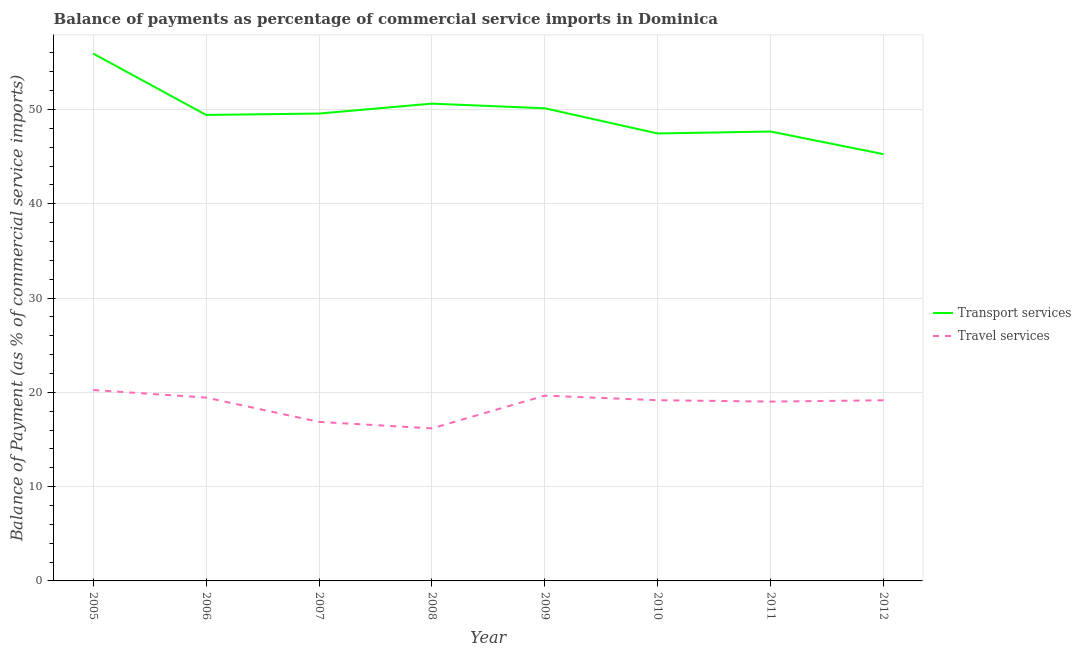How many different coloured lines are there?
Ensure brevity in your answer.  2. What is the balance of payments of travel services in 2005?
Your response must be concise. 20.25. Across all years, what is the maximum balance of payments of transport services?
Give a very brief answer. 55.92. Across all years, what is the minimum balance of payments of travel services?
Your answer should be very brief. 16.18. In which year was the balance of payments of transport services minimum?
Offer a very short reply. 2012. What is the total balance of payments of travel services in the graph?
Offer a very short reply. 149.72. What is the difference between the balance of payments of travel services in 2007 and that in 2010?
Your answer should be very brief. -2.3. What is the difference between the balance of payments of transport services in 2010 and the balance of payments of travel services in 2009?
Your answer should be very brief. 27.8. What is the average balance of payments of transport services per year?
Make the answer very short. 49.5. In the year 2012, what is the difference between the balance of payments of transport services and balance of payments of travel services?
Provide a short and direct response. 26.11. What is the ratio of the balance of payments of travel services in 2005 to that in 2011?
Ensure brevity in your answer.  1.06. Is the balance of payments of travel services in 2008 less than that in 2012?
Provide a short and direct response. Yes. Is the difference between the balance of payments of transport services in 2008 and 2009 greater than the difference between the balance of payments of travel services in 2008 and 2009?
Your answer should be very brief. Yes. What is the difference between the highest and the second highest balance of payments of transport services?
Your response must be concise. 5.31. What is the difference between the highest and the lowest balance of payments of transport services?
Provide a short and direct response. 10.66. Is the sum of the balance of payments of transport services in 2005 and 2006 greater than the maximum balance of payments of travel services across all years?
Offer a very short reply. Yes. Is the balance of payments of transport services strictly less than the balance of payments of travel services over the years?
Provide a succinct answer. No. How many lines are there?
Provide a succinct answer. 2. How many years are there in the graph?
Your answer should be very brief. 8. What is the difference between two consecutive major ticks on the Y-axis?
Provide a short and direct response. 10. Are the values on the major ticks of Y-axis written in scientific E-notation?
Keep it short and to the point. No. Does the graph contain any zero values?
Provide a succinct answer. No. Does the graph contain grids?
Ensure brevity in your answer.  Yes. Where does the legend appear in the graph?
Your answer should be very brief. Center right. How many legend labels are there?
Provide a succinct answer. 2. How are the legend labels stacked?
Provide a succinct answer. Vertical. What is the title of the graph?
Offer a terse response. Balance of payments as percentage of commercial service imports in Dominica. What is the label or title of the Y-axis?
Provide a succinct answer. Balance of Payment (as % of commercial service imports). What is the Balance of Payment (as % of commercial service imports) in Transport services in 2005?
Give a very brief answer. 55.92. What is the Balance of Payment (as % of commercial service imports) of Travel services in 2005?
Provide a succinct answer. 20.25. What is the Balance of Payment (as % of commercial service imports) of Transport services in 2006?
Offer a terse response. 49.42. What is the Balance of Payment (as % of commercial service imports) of Travel services in 2006?
Keep it short and to the point. 19.44. What is the Balance of Payment (as % of commercial service imports) in Transport services in 2007?
Provide a short and direct response. 49.57. What is the Balance of Payment (as % of commercial service imports) of Travel services in 2007?
Your response must be concise. 16.87. What is the Balance of Payment (as % of commercial service imports) of Transport services in 2008?
Offer a very short reply. 50.62. What is the Balance of Payment (as % of commercial service imports) of Travel services in 2008?
Your answer should be very brief. 16.18. What is the Balance of Payment (as % of commercial service imports) of Transport services in 2009?
Keep it short and to the point. 50.12. What is the Balance of Payment (as % of commercial service imports) of Travel services in 2009?
Provide a succinct answer. 19.65. What is the Balance of Payment (as % of commercial service imports) of Transport services in 2010?
Provide a succinct answer. 47.45. What is the Balance of Payment (as % of commercial service imports) of Travel services in 2010?
Keep it short and to the point. 19.17. What is the Balance of Payment (as % of commercial service imports) of Transport services in 2011?
Keep it short and to the point. 47.66. What is the Balance of Payment (as % of commercial service imports) of Travel services in 2011?
Keep it short and to the point. 19.02. What is the Balance of Payment (as % of commercial service imports) in Transport services in 2012?
Give a very brief answer. 45.26. What is the Balance of Payment (as % of commercial service imports) of Travel services in 2012?
Offer a terse response. 19.16. Across all years, what is the maximum Balance of Payment (as % of commercial service imports) of Transport services?
Ensure brevity in your answer.  55.92. Across all years, what is the maximum Balance of Payment (as % of commercial service imports) in Travel services?
Your response must be concise. 20.25. Across all years, what is the minimum Balance of Payment (as % of commercial service imports) in Transport services?
Offer a very short reply. 45.26. Across all years, what is the minimum Balance of Payment (as % of commercial service imports) of Travel services?
Ensure brevity in your answer.  16.18. What is the total Balance of Payment (as % of commercial service imports) in Transport services in the graph?
Offer a very short reply. 396.03. What is the total Balance of Payment (as % of commercial service imports) of Travel services in the graph?
Your response must be concise. 149.72. What is the difference between the Balance of Payment (as % of commercial service imports) of Transport services in 2005 and that in 2006?
Offer a very short reply. 6.5. What is the difference between the Balance of Payment (as % of commercial service imports) in Travel services in 2005 and that in 2006?
Provide a succinct answer. 0.8. What is the difference between the Balance of Payment (as % of commercial service imports) in Transport services in 2005 and that in 2007?
Keep it short and to the point. 6.36. What is the difference between the Balance of Payment (as % of commercial service imports) of Travel services in 2005 and that in 2007?
Make the answer very short. 3.38. What is the difference between the Balance of Payment (as % of commercial service imports) in Transport services in 2005 and that in 2008?
Provide a succinct answer. 5.31. What is the difference between the Balance of Payment (as % of commercial service imports) of Travel services in 2005 and that in 2008?
Provide a succinct answer. 4.07. What is the difference between the Balance of Payment (as % of commercial service imports) of Transport services in 2005 and that in 2009?
Offer a very short reply. 5.8. What is the difference between the Balance of Payment (as % of commercial service imports) in Travel services in 2005 and that in 2009?
Your response must be concise. 0.6. What is the difference between the Balance of Payment (as % of commercial service imports) in Transport services in 2005 and that in 2010?
Your answer should be very brief. 8.47. What is the difference between the Balance of Payment (as % of commercial service imports) in Travel services in 2005 and that in 2010?
Provide a succinct answer. 1.08. What is the difference between the Balance of Payment (as % of commercial service imports) in Transport services in 2005 and that in 2011?
Your response must be concise. 8.26. What is the difference between the Balance of Payment (as % of commercial service imports) of Travel services in 2005 and that in 2011?
Offer a very short reply. 1.23. What is the difference between the Balance of Payment (as % of commercial service imports) of Transport services in 2005 and that in 2012?
Offer a very short reply. 10.66. What is the difference between the Balance of Payment (as % of commercial service imports) in Travel services in 2005 and that in 2012?
Your response must be concise. 1.09. What is the difference between the Balance of Payment (as % of commercial service imports) of Transport services in 2006 and that in 2007?
Your answer should be compact. -0.15. What is the difference between the Balance of Payment (as % of commercial service imports) of Travel services in 2006 and that in 2007?
Provide a short and direct response. 2.58. What is the difference between the Balance of Payment (as % of commercial service imports) of Transport services in 2006 and that in 2008?
Make the answer very short. -1.2. What is the difference between the Balance of Payment (as % of commercial service imports) in Travel services in 2006 and that in 2008?
Make the answer very short. 3.26. What is the difference between the Balance of Payment (as % of commercial service imports) of Transport services in 2006 and that in 2009?
Make the answer very short. -0.7. What is the difference between the Balance of Payment (as % of commercial service imports) in Travel services in 2006 and that in 2009?
Offer a terse response. -0.21. What is the difference between the Balance of Payment (as % of commercial service imports) in Transport services in 2006 and that in 2010?
Give a very brief answer. 1.97. What is the difference between the Balance of Payment (as % of commercial service imports) of Travel services in 2006 and that in 2010?
Provide a short and direct response. 0.28. What is the difference between the Balance of Payment (as % of commercial service imports) in Transport services in 2006 and that in 2011?
Your response must be concise. 1.76. What is the difference between the Balance of Payment (as % of commercial service imports) of Travel services in 2006 and that in 2011?
Your response must be concise. 0.43. What is the difference between the Balance of Payment (as % of commercial service imports) of Transport services in 2006 and that in 2012?
Ensure brevity in your answer.  4.16. What is the difference between the Balance of Payment (as % of commercial service imports) in Travel services in 2006 and that in 2012?
Give a very brief answer. 0.29. What is the difference between the Balance of Payment (as % of commercial service imports) of Transport services in 2007 and that in 2008?
Provide a succinct answer. -1.05. What is the difference between the Balance of Payment (as % of commercial service imports) in Travel services in 2007 and that in 2008?
Provide a short and direct response. 0.69. What is the difference between the Balance of Payment (as % of commercial service imports) of Transport services in 2007 and that in 2009?
Keep it short and to the point. -0.56. What is the difference between the Balance of Payment (as % of commercial service imports) of Travel services in 2007 and that in 2009?
Offer a very short reply. -2.78. What is the difference between the Balance of Payment (as % of commercial service imports) in Transport services in 2007 and that in 2010?
Offer a terse response. 2.11. What is the difference between the Balance of Payment (as % of commercial service imports) of Travel services in 2007 and that in 2010?
Ensure brevity in your answer.  -2.3. What is the difference between the Balance of Payment (as % of commercial service imports) in Transport services in 2007 and that in 2011?
Your answer should be very brief. 1.9. What is the difference between the Balance of Payment (as % of commercial service imports) of Travel services in 2007 and that in 2011?
Provide a short and direct response. -2.15. What is the difference between the Balance of Payment (as % of commercial service imports) of Transport services in 2007 and that in 2012?
Your answer should be compact. 4.3. What is the difference between the Balance of Payment (as % of commercial service imports) of Travel services in 2007 and that in 2012?
Provide a short and direct response. -2.29. What is the difference between the Balance of Payment (as % of commercial service imports) of Transport services in 2008 and that in 2009?
Provide a short and direct response. 0.49. What is the difference between the Balance of Payment (as % of commercial service imports) of Travel services in 2008 and that in 2009?
Make the answer very short. -3.47. What is the difference between the Balance of Payment (as % of commercial service imports) of Transport services in 2008 and that in 2010?
Provide a succinct answer. 3.16. What is the difference between the Balance of Payment (as % of commercial service imports) of Travel services in 2008 and that in 2010?
Offer a very short reply. -2.99. What is the difference between the Balance of Payment (as % of commercial service imports) of Transport services in 2008 and that in 2011?
Your response must be concise. 2.96. What is the difference between the Balance of Payment (as % of commercial service imports) of Travel services in 2008 and that in 2011?
Ensure brevity in your answer.  -2.84. What is the difference between the Balance of Payment (as % of commercial service imports) of Transport services in 2008 and that in 2012?
Keep it short and to the point. 5.36. What is the difference between the Balance of Payment (as % of commercial service imports) in Travel services in 2008 and that in 2012?
Provide a short and direct response. -2.98. What is the difference between the Balance of Payment (as % of commercial service imports) in Transport services in 2009 and that in 2010?
Ensure brevity in your answer.  2.67. What is the difference between the Balance of Payment (as % of commercial service imports) in Travel services in 2009 and that in 2010?
Make the answer very short. 0.48. What is the difference between the Balance of Payment (as % of commercial service imports) of Transport services in 2009 and that in 2011?
Keep it short and to the point. 2.46. What is the difference between the Balance of Payment (as % of commercial service imports) in Travel services in 2009 and that in 2011?
Your answer should be compact. 0.63. What is the difference between the Balance of Payment (as % of commercial service imports) in Transport services in 2009 and that in 2012?
Provide a succinct answer. 4.86. What is the difference between the Balance of Payment (as % of commercial service imports) of Travel services in 2009 and that in 2012?
Keep it short and to the point. 0.49. What is the difference between the Balance of Payment (as % of commercial service imports) of Transport services in 2010 and that in 2011?
Give a very brief answer. -0.21. What is the difference between the Balance of Payment (as % of commercial service imports) of Travel services in 2010 and that in 2011?
Your answer should be very brief. 0.15. What is the difference between the Balance of Payment (as % of commercial service imports) in Transport services in 2010 and that in 2012?
Your answer should be compact. 2.19. What is the difference between the Balance of Payment (as % of commercial service imports) of Travel services in 2010 and that in 2012?
Give a very brief answer. 0.01. What is the difference between the Balance of Payment (as % of commercial service imports) of Transport services in 2011 and that in 2012?
Provide a short and direct response. 2.4. What is the difference between the Balance of Payment (as % of commercial service imports) in Travel services in 2011 and that in 2012?
Give a very brief answer. -0.14. What is the difference between the Balance of Payment (as % of commercial service imports) of Transport services in 2005 and the Balance of Payment (as % of commercial service imports) of Travel services in 2006?
Give a very brief answer. 36.48. What is the difference between the Balance of Payment (as % of commercial service imports) in Transport services in 2005 and the Balance of Payment (as % of commercial service imports) in Travel services in 2007?
Ensure brevity in your answer.  39.06. What is the difference between the Balance of Payment (as % of commercial service imports) in Transport services in 2005 and the Balance of Payment (as % of commercial service imports) in Travel services in 2008?
Provide a succinct answer. 39.74. What is the difference between the Balance of Payment (as % of commercial service imports) in Transport services in 2005 and the Balance of Payment (as % of commercial service imports) in Travel services in 2009?
Offer a very short reply. 36.27. What is the difference between the Balance of Payment (as % of commercial service imports) of Transport services in 2005 and the Balance of Payment (as % of commercial service imports) of Travel services in 2010?
Your answer should be compact. 36.76. What is the difference between the Balance of Payment (as % of commercial service imports) in Transport services in 2005 and the Balance of Payment (as % of commercial service imports) in Travel services in 2011?
Offer a terse response. 36.91. What is the difference between the Balance of Payment (as % of commercial service imports) of Transport services in 2005 and the Balance of Payment (as % of commercial service imports) of Travel services in 2012?
Provide a succinct answer. 36.77. What is the difference between the Balance of Payment (as % of commercial service imports) of Transport services in 2006 and the Balance of Payment (as % of commercial service imports) of Travel services in 2007?
Your answer should be compact. 32.55. What is the difference between the Balance of Payment (as % of commercial service imports) of Transport services in 2006 and the Balance of Payment (as % of commercial service imports) of Travel services in 2008?
Ensure brevity in your answer.  33.24. What is the difference between the Balance of Payment (as % of commercial service imports) of Transport services in 2006 and the Balance of Payment (as % of commercial service imports) of Travel services in 2009?
Offer a very short reply. 29.77. What is the difference between the Balance of Payment (as % of commercial service imports) in Transport services in 2006 and the Balance of Payment (as % of commercial service imports) in Travel services in 2010?
Ensure brevity in your answer.  30.25. What is the difference between the Balance of Payment (as % of commercial service imports) of Transport services in 2006 and the Balance of Payment (as % of commercial service imports) of Travel services in 2011?
Your response must be concise. 30.4. What is the difference between the Balance of Payment (as % of commercial service imports) in Transport services in 2006 and the Balance of Payment (as % of commercial service imports) in Travel services in 2012?
Provide a short and direct response. 30.26. What is the difference between the Balance of Payment (as % of commercial service imports) of Transport services in 2007 and the Balance of Payment (as % of commercial service imports) of Travel services in 2008?
Make the answer very short. 33.39. What is the difference between the Balance of Payment (as % of commercial service imports) of Transport services in 2007 and the Balance of Payment (as % of commercial service imports) of Travel services in 2009?
Offer a terse response. 29.92. What is the difference between the Balance of Payment (as % of commercial service imports) in Transport services in 2007 and the Balance of Payment (as % of commercial service imports) in Travel services in 2010?
Provide a succinct answer. 30.4. What is the difference between the Balance of Payment (as % of commercial service imports) in Transport services in 2007 and the Balance of Payment (as % of commercial service imports) in Travel services in 2011?
Provide a short and direct response. 30.55. What is the difference between the Balance of Payment (as % of commercial service imports) in Transport services in 2007 and the Balance of Payment (as % of commercial service imports) in Travel services in 2012?
Give a very brief answer. 30.41. What is the difference between the Balance of Payment (as % of commercial service imports) of Transport services in 2008 and the Balance of Payment (as % of commercial service imports) of Travel services in 2009?
Offer a very short reply. 30.97. What is the difference between the Balance of Payment (as % of commercial service imports) of Transport services in 2008 and the Balance of Payment (as % of commercial service imports) of Travel services in 2010?
Your answer should be compact. 31.45. What is the difference between the Balance of Payment (as % of commercial service imports) in Transport services in 2008 and the Balance of Payment (as % of commercial service imports) in Travel services in 2011?
Give a very brief answer. 31.6. What is the difference between the Balance of Payment (as % of commercial service imports) in Transport services in 2008 and the Balance of Payment (as % of commercial service imports) in Travel services in 2012?
Offer a very short reply. 31.46. What is the difference between the Balance of Payment (as % of commercial service imports) of Transport services in 2009 and the Balance of Payment (as % of commercial service imports) of Travel services in 2010?
Make the answer very short. 30.96. What is the difference between the Balance of Payment (as % of commercial service imports) of Transport services in 2009 and the Balance of Payment (as % of commercial service imports) of Travel services in 2011?
Offer a terse response. 31.11. What is the difference between the Balance of Payment (as % of commercial service imports) of Transport services in 2009 and the Balance of Payment (as % of commercial service imports) of Travel services in 2012?
Provide a succinct answer. 30.97. What is the difference between the Balance of Payment (as % of commercial service imports) of Transport services in 2010 and the Balance of Payment (as % of commercial service imports) of Travel services in 2011?
Make the answer very short. 28.44. What is the difference between the Balance of Payment (as % of commercial service imports) of Transport services in 2010 and the Balance of Payment (as % of commercial service imports) of Travel services in 2012?
Provide a short and direct response. 28.3. What is the difference between the Balance of Payment (as % of commercial service imports) in Transport services in 2011 and the Balance of Payment (as % of commercial service imports) in Travel services in 2012?
Ensure brevity in your answer.  28.51. What is the average Balance of Payment (as % of commercial service imports) of Transport services per year?
Offer a very short reply. 49.5. What is the average Balance of Payment (as % of commercial service imports) in Travel services per year?
Offer a very short reply. 18.72. In the year 2005, what is the difference between the Balance of Payment (as % of commercial service imports) of Transport services and Balance of Payment (as % of commercial service imports) of Travel services?
Your answer should be very brief. 35.68. In the year 2006, what is the difference between the Balance of Payment (as % of commercial service imports) in Transport services and Balance of Payment (as % of commercial service imports) in Travel services?
Your answer should be compact. 29.98. In the year 2007, what is the difference between the Balance of Payment (as % of commercial service imports) of Transport services and Balance of Payment (as % of commercial service imports) of Travel services?
Offer a terse response. 32.7. In the year 2008, what is the difference between the Balance of Payment (as % of commercial service imports) in Transport services and Balance of Payment (as % of commercial service imports) in Travel services?
Make the answer very short. 34.44. In the year 2009, what is the difference between the Balance of Payment (as % of commercial service imports) of Transport services and Balance of Payment (as % of commercial service imports) of Travel services?
Keep it short and to the point. 30.47. In the year 2010, what is the difference between the Balance of Payment (as % of commercial service imports) in Transport services and Balance of Payment (as % of commercial service imports) in Travel services?
Provide a succinct answer. 28.29. In the year 2011, what is the difference between the Balance of Payment (as % of commercial service imports) in Transport services and Balance of Payment (as % of commercial service imports) in Travel services?
Your answer should be compact. 28.65. In the year 2012, what is the difference between the Balance of Payment (as % of commercial service imports) of Transport services and Balance of Payment (as % of commercial service imports) of Travel services?
Your answer should be very brief. 26.11. What is the ratio of the Balance of Payment (as % of commercial service imports) in Transport services in 2005 to that in 2006?
Offer a terse response. 1.13. What is the ratio of the Balance of Payment (as % of commercial service imports) in Travel services in 2005 to that in 2006?
Make the answer very short. 1.04. What is the ratio of the Balance of Payment (as % of commercial service imports) of Transport services in 2005 to that in 2007?
Offer a very short reply. 1.13. What is the ratio of the Balance of Payment (as % of commercial service imports) in Travel services in 2005 to that in 2007?
Make the answer very short. 1.2. What is the ratio of the Balance of Payment (as % of commercial service imports) in Transport services in 2005 to that in 2008?
Keep it short and to the point. 1.1. What is the ratio of the Balance of Payment (as % of commercial service imports) in Travel services in 2005 to that in 2008?
Keep it short and to the point. 1.25. What is the ratio of the Balance of Payment (as % of commercial service imports) of Transport services in 2005 to that in 2009?
Ensure brevity in your answer.  1.12. What is the ratio of the Balance of Payment (as % of commercial service imports) in Travel services in 2005 to that in 2009?
Provide a succinct answer. 1.03. What is the ratio of the Balance of Payment (as % of commercial service imports) of Transport services in 2005 to that in 2010?
Your answer should be compact. 1.18. What is the ratio of the Balance of Payment (as % of commercial service imports) of Travel services in 2005 to that in 2010?
Provide a succinct answer. 1.06. What is the ratio of the Balance of Payment (as % of commercial service imports) of Transport services in 2005 to that in 2011?
Your answer should be compact. 1.17. What is the ratio of the Balance of Payment (as % of commercial service imports) of Travel services in 2005 to that in 2011?
Provide a succinct answer. 1.06. What is the ratio of the Balance of Payment (as % of commercial service imports) of Transport services in 2005 to that in 2012?
Provide a short and direct response. 1.24. What is the ratio of the Balance of Payment (as % of commercial service imports) of Travel services in 2005 to that in 2012?
Give a very brief answer. 1.06. What is the ratio of the Balance of Payment (as % of commercial service imports) of Transport services in 2006 to that in 2007?
Your answer should be very brief. 1. What is the ratio of the Balance of Payment (as % of commercial service imports) in Travel services in 2006 to that in 2007?
Your answer should be very brief. 1.15. What is the ratio of the Balance of Payment (as % of commercial service imports) of Transport services in 2006 to that in 2008?
Make the answer very short. 0.98. What is the ratio of the Balance of Payment (as % of commercial service imports) of Travel services in 2006 to that in 2008?
Give a very brief answer. 1.2. What is the ratio of the Balance of Payment (as % of commercial service imports) in Transport services in 2006 to that in 2010?
Give a very brief answer. 1.04. What is the ratio of the Balance of Payment (as % of commercial service imports) in Travel services in 2006 to that in 2010?
Your answer should be very brief. 1.01. What is the ratio of the Balance of Payment (as % of commercial service imports) of Transport services in 2006 to that in 2011?
Give a very brief answer. 1.04. What is the ratio of the Balance of Payment (as % of commercial service imports) of Travel services in 2006 to that in 2011?
Your answer should be very brief. 1.02. What is the ratio of the Balance of Payment (as % of commercial service imports) in Transport services in 2006 to that in 2012?
Provide a succinct answer. 1.09. What is the ratio of the Balance of Payment (as % of commercial service imports) of Travel services in 2006 to that in 2012?
Provide a short and direct response. 1.01. What is the ratio of the Balance of Payment (as % of commercial service imports) in Transport services in 2007 to that in 2008?
Offer a very short reply. 0.98. What is the ratio of the Balance of Payment (as % of commercial service imports) in Travel services in 2007 to that in 2008?
Your answer should be very brief. 1.04. What is the ratio of the Balance of Payment (as % of commercial service imports) of Transport services in 2007 to that in 2009?
Provide a short and direct response. 0.99. What is the ratio of the Balance of Payment (as % of commercial service imports) in Travel services in 2007 to that in 2009?
Your answer should be very brief. 0.86. What is the ratio of the Balance of Payment (as % of commercial service imports) of Transport services in 2007 to that in 2010?
Your answer should be very brief. 1.04. What is the ratio of the Balance of Payment (as % of commercial service imports) of Transport services in 2007 to that in 2011?
Provide a short and direct response. 1.04. What is the ratio of the Balance of Payment (as % of commercial service imports) in Travel services in 2007 to that in 2011?
Give a very brief answer. 0.89. What is the ratio of the Balance of Payment (as % of commercial service imports) in Transport services in 2007 to that in 2012?
Provide a succinct answer. 1.09. What is the ratio of the Balance of Payment (as % of commercial service imports) in Travel services in 2007 to that in 2012?
Make the answer very short. 0.88. What is the ratio of the Balance of Payment (as % of commercial service imports) in Transport services in 2008 to that in 2009?
Make the answer very short. 1.01. What is the ratio of the Balance of Payment (as % of commercial service imports) in Travel services in 2008 to that in 2009?
Ensure brevity in your answer.  0.82. What is the ratio of the Balance of Payment (as % of commercial service imports) in Transport services in 2008 to that in 2010?
Offer a terse response. 1.07. What is the ratio of the Balance of Payment (as % of commercial service imports) of Travel services in 2008 to that in 2010?
Provide a short and direct response. 0.84. What is the ratio of the Balance of Payment (as % of commercial service imports) of Transport services in 2008 to that in 2011?
Provide a succinct answer. 1.06. What is the ratio of the Balance of Payment (as % of commercial service imports) in Travel services in 2008 to that in 2011?
Your response must be concise. 0.85. What is the ratio of the Balance of Payment (as % of commercial service imports) in Transport services in 2008 to that in 2012?
Your answer should be compact. 1.12. What is the ratio of the Balance of Payment (as % of commercial service imports) of Travel services in 2008 to that in 2012?
Your response must be concise. 0.84. What is the ratio of the Balance of Payment (as % of commercial service imports) in Transport services in 2009 to that in 2010?
Offer a terse response. 1.06. What is the ratio of the Balance of Payment (as % of commercial service imports) of Travel services in 2009 to that in 2010?
Keep it short and to the point. 1.03. What is the ratio of the Balance of Payment (as % of commercial service imports) of Transport services in 2009 to that in 2011?
Give a very brief answer. 1.05. What is the ratio of the Balance of Payment (as % of commercial service imports) of Travel services in 2009 to that in 2011?
Offer a very short reply. 1.03. What is the ratio of the Balance of Payment (as % of commercial service imports) in Transport services in 2009 to that in 2012?
Offer a very short reply. 1.11. What is the ratio of the Balance of Payment (as % of commercial service imports) of Travel services in 2009 to that in 2012?
Your answer should be compact. 1.03. What is the ratio of the Balance of Payment (as % of commercial service imports) in Transport services in 2010 to that in 2012?
Your answer should be compact. 1.05. What is the ratio of the Balance of Payment (as % of commercial service imports) of Travel services in 2010 to that in 2012?
Give a very brief answer. 1. What is the ratio of the Balance of Payment (as % of commercial service imports) of Transport services in 2011 to that in 2012?
Provide a succinct answer. 1.05. What is the difference between the highest and the second highest Balance of Payment (as % of commercial service imports) in Transport services?
Give a very brief answer. 5.31. What is the difference between the highest and the second highest Balance of Payment (as % of commercial service imports) in Travel services?
Provide a short and direct response. 0.6. What is the difference between the highest and the lowest Balance of Payment (as % of commercial service imports) in Transport services?
Offer a terse response. 10.66. What is the difference between the highest and the lowest Balance of Payment (as % of commercial service imports) in Travel services?
Provide a short and direct response. 4.07. 